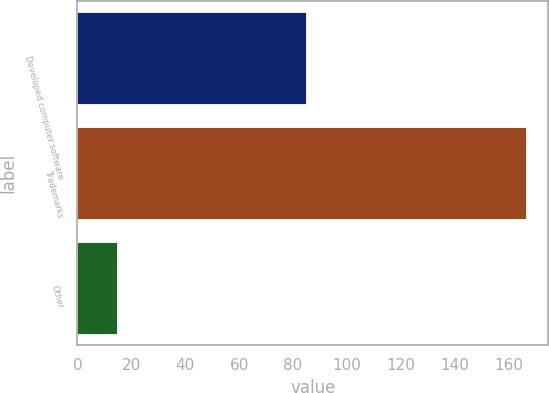Convert chart. <chart><loc_0><loc_0><loc_500><loc_500><bar_chart><fcel>Developed computer software<fcel>Trademarks<fcel>Other<nl><fcel>84.9<fcel>166.3<fcel>14.8<nl></chart> 